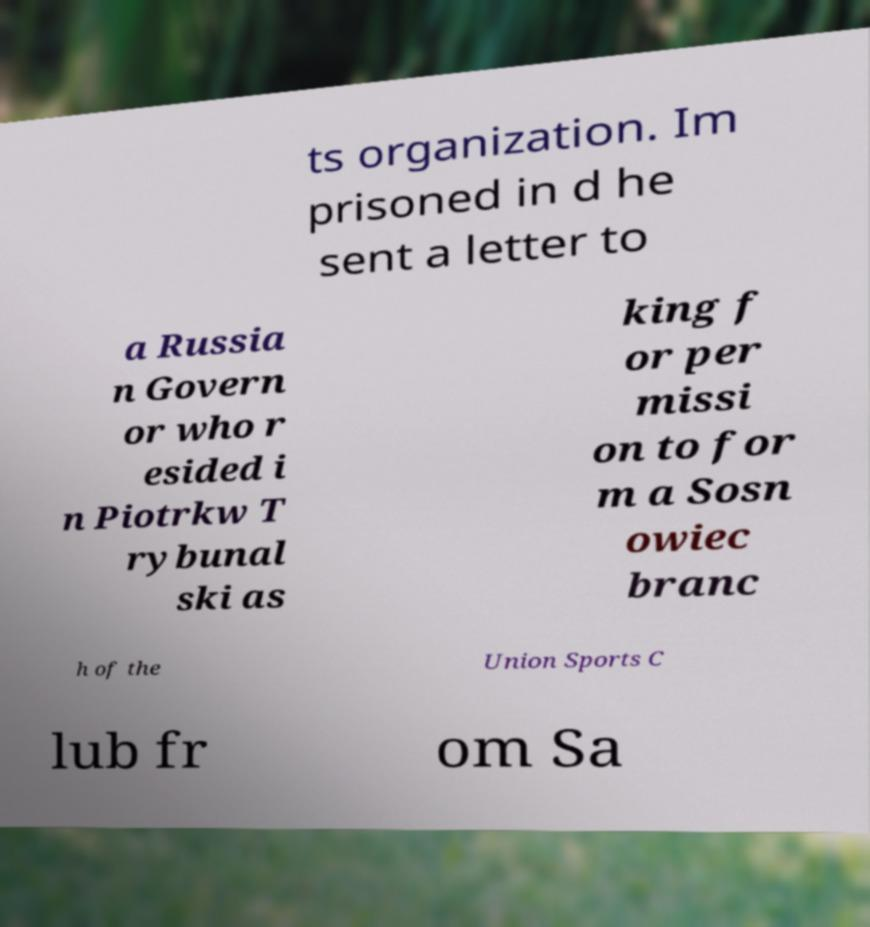I need the written content from this picture converted into text. Can you do that? ts organization. Im prisoned in d he sent a letter to a Russia n Govern or who r esided i n Piotrkw T rybunal ski as king f or per missi on to for m a Sosn owiec branc h of the Union Sports C lub fr om Sa 